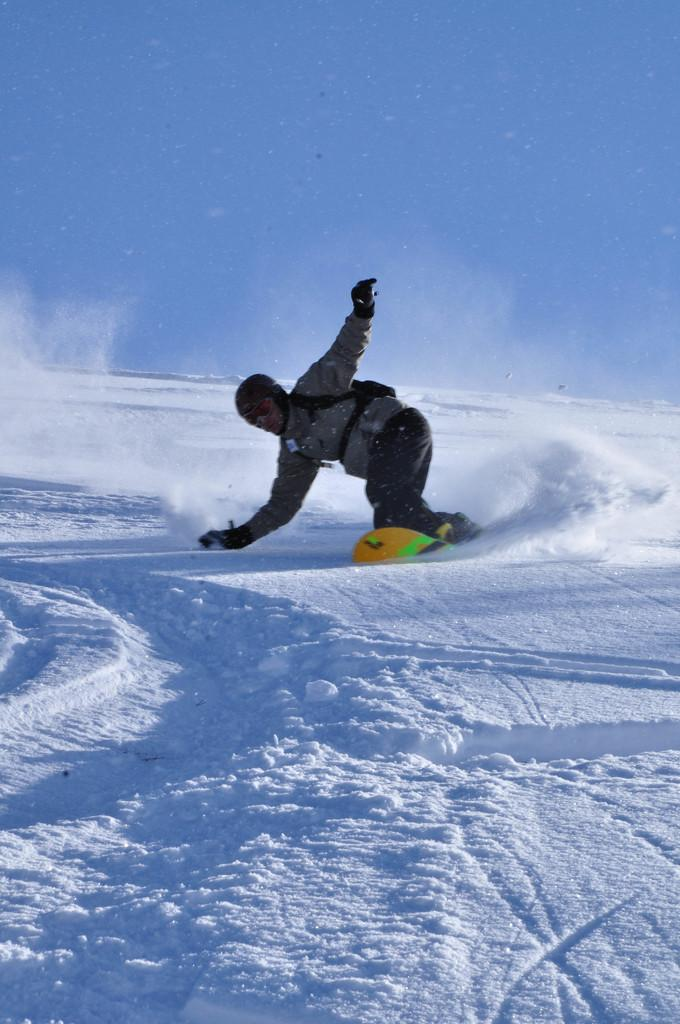What is the person in the image wearing on their head? The person is wearing a helmet in the image. What type of eyewear is the person wearing? The person is wearing goggles in the image. What type of gloves is the person wearing? The person is wearing gloves in the image. What is the person doing in the image? The person is skiing on a ski board in the image. What type of terrain is the person skiing on? The person is skiing on the snow in the image. What can be seen in the background of the image? The sky is visible in the background of the image. What type of humor can be seen in the image? There is no humor present in the image. What type of glue is being used by the person in the image? There is no glue present in the image. Is there a donkey present in the image? There is no donkey present in the image. 